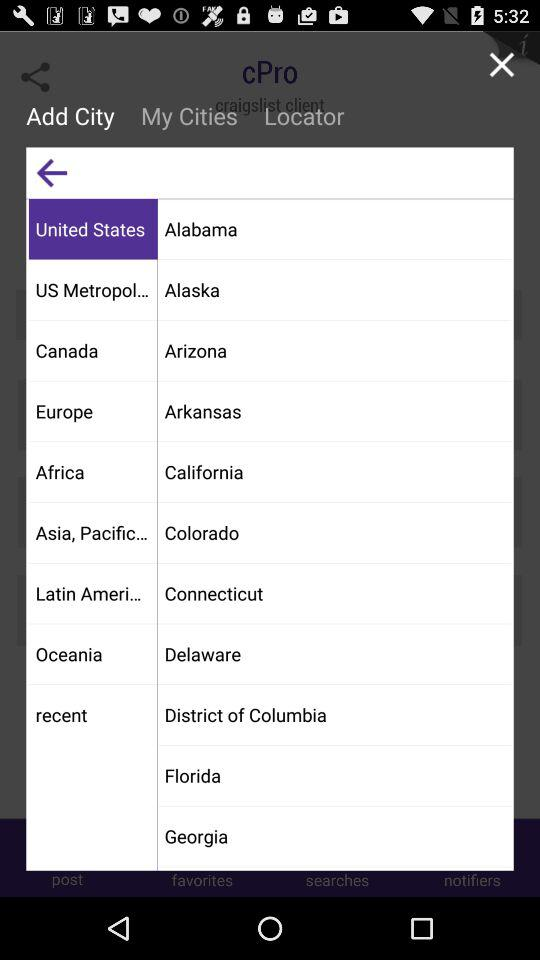What option is selected? The selected options are "Add City" and "United States". 